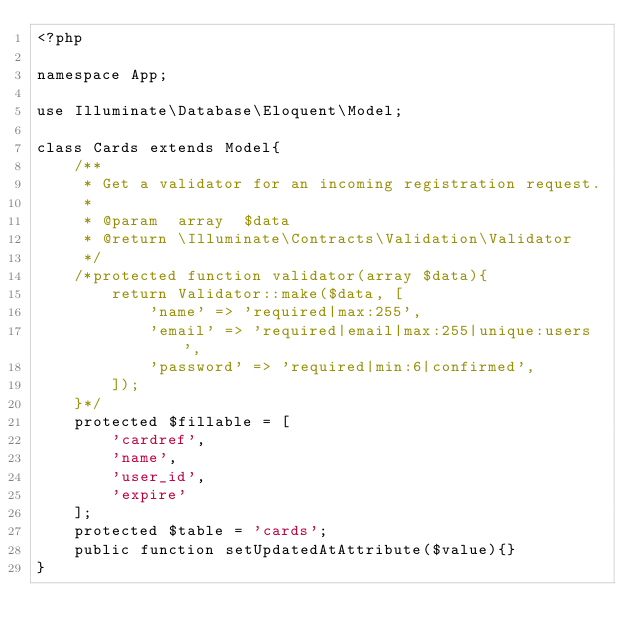Convert code to text. <code><loc_0><loc_0><loc_500><loc_500><_PHP_><?php

namespace App;

use Illuminate\Database\Eloquent\Model;

class Cards extends Model{
    /**
     * Get a validator for an incoming registration request.
     *
     * @param  array  $data
     * @return \Illuminate\Contracts\Validation\Validator
     */
    /*protected function validator(array $data){
        return Validator::make($data, [
            'name' => 'required|max:255',
            'email' => 'required|email|max:255|unique:users',
            'password' => 'required|min:6|confirmed',
        ]);
    }*/
    protected $fillable = [
        'cardref',
        'name',
        'user_id',
        'expire'
    ];
    protected $table = 'cards';
    public function setUpdatedAtAttribute($value){}
}
</code> 